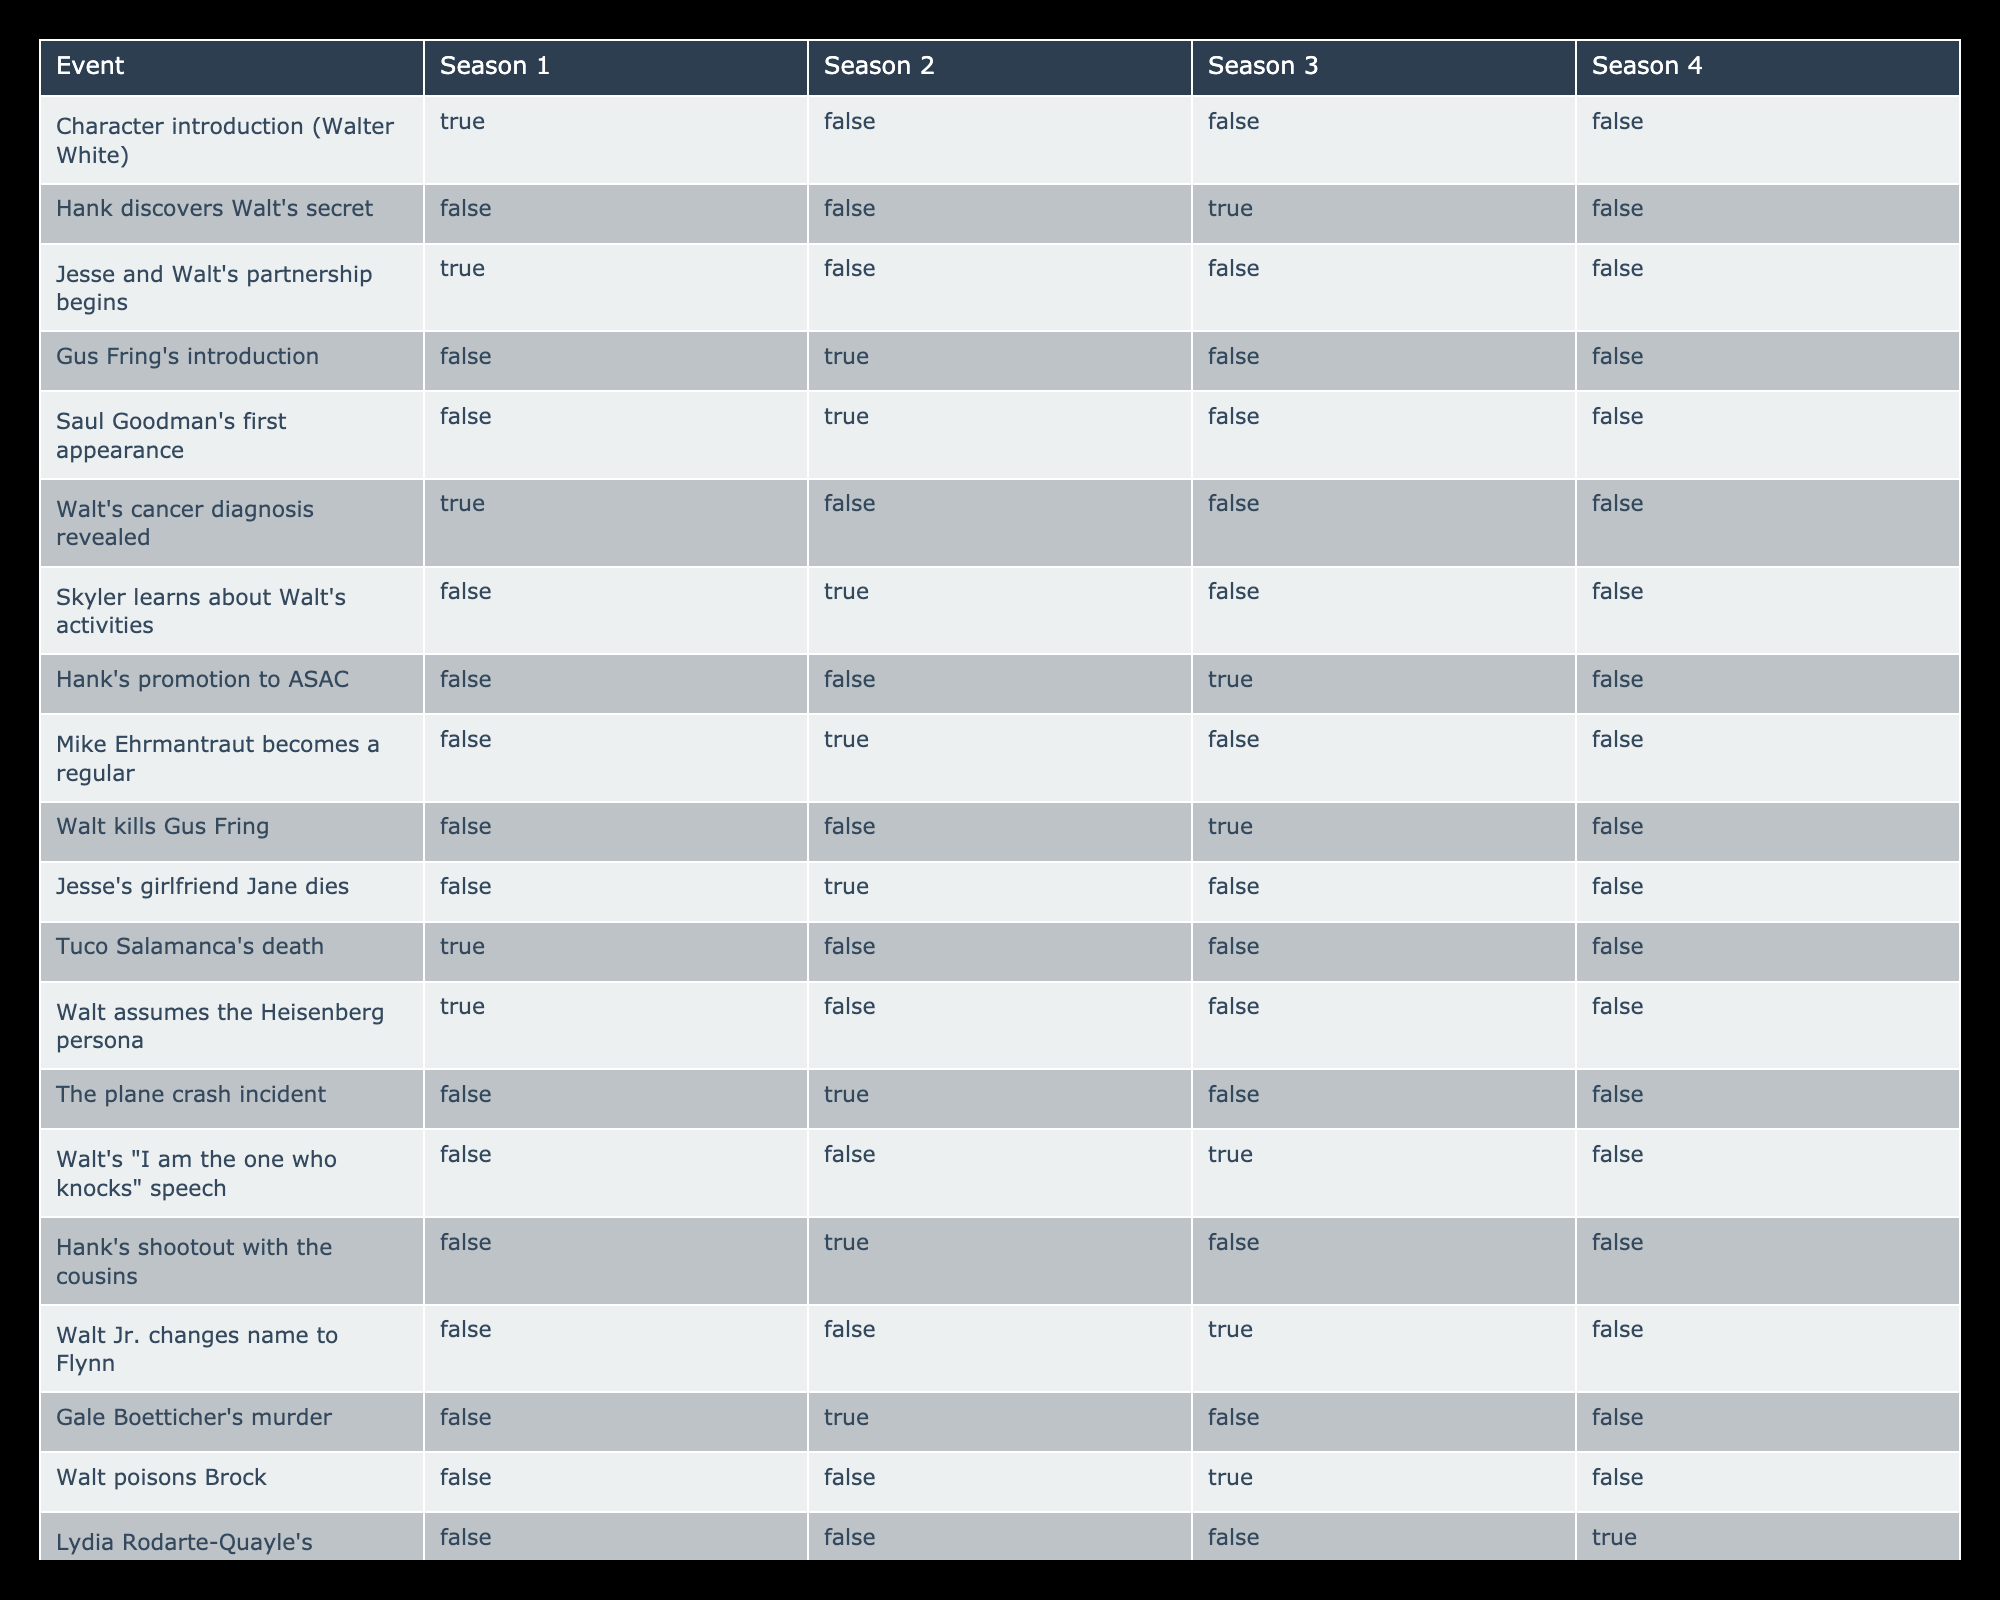What event occurs in Season 1 but not in subsequent seasons? Referring to the table, Walter White's character introduction occurs in Season 1 and is marked TRUE only for that season. Therefore, it does not occur again in Seasons 2, 3, or 4.
Answer: Walter White's character introduction How many events occur in Season 2? By inspecting the table for Season 2, the TRUE values indicate that there are 6 distinct events that occur in that season: Gus Fring's introduction, Saul Goodman's first appearance, Skyler learns about Walt's activities, Mike Ehrmantraut becomes a regular, Jesse's girlfriend Jane dies, and Hank's shootout with the cousins.
Answer: 6 Is Walt's cancer diagnosis revealed in Season 3? The table shows that Walt's cancer diagnosis is marked TRUE only in Season 1. Therefore, it is not revealed again in Season 3.
Answer: No In which seasons does Jesse's girlfriend Jane die? The table indicates that Jesse's girlfriend Jane dies in Season 2 and does not appear in subsequent seasons. Thus, it occurs only in Season 2 marked as TRUE.
Answer: Season 2 What is the total number of unique events across all seasons that involve character introductions? The events that involve character introductions are Walter White in Season 1, Gus Fring in Season 2, Mike Ehrmantraut in Season 2, and Lydia Rodarte-Quayle in Season 4. In total, there are 4 events where character introductions occur.
Answer: 4 Is it true that Walt kills Gus Fring in Season 2? The table indicates that Walt kills Gus Fring is marked as TRUE in Season 3, not in Season 2. Therefore, this statement is false.
Answer: No In how many seasons does Hank discover Walt's secret? Based on the table, Hank discovers Walt's secret marked as TRUE in Season 3, and it does not occur in other seasons. Hence, this event is exclusive to Season 3.
Answer: 1 Which event marks the transition of Walt to the Heisenberg persona? The table marks the transition to the Heisenberg persona as TRUE in Season 1. Therefore, this is the only season when this event occurs.
Answer: Season 1 How many events are shown to occur in Season 4? Looking at the table, Season 4 has only 2 events marked as TRUE: Walt's cancer diagnosis revealed and Lydia Rodarte-Quayle's introduction. Thus, there are 2 events in Season 4.
Answer: 2 